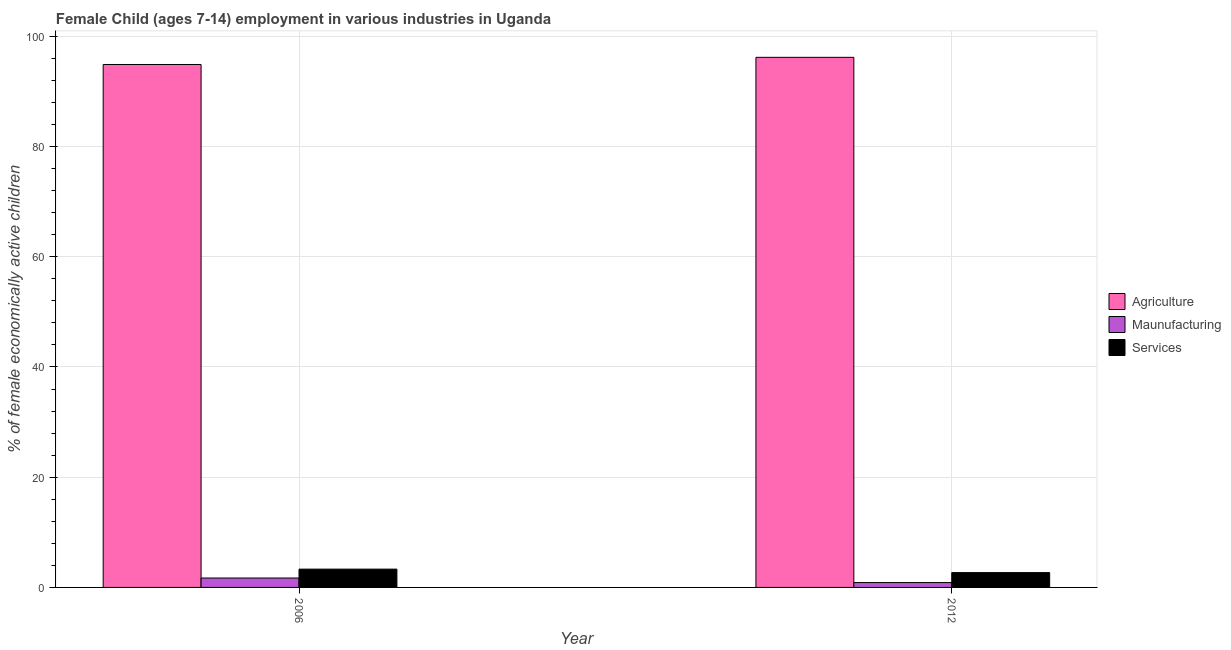Are the number of bars on each tick of the X-axis equal?
Your response must be concise. Yes. What is the label of the 2nd group of bars from the left?
Offer a terse response. 2012. What is the percentage of economically active children in services in 2006?
Keep it short and to the point. 3.32. Across all years, what is the maximum percentage of economically active children in manufacturing?
Provide a short and direct response. 1.71. Across all years, what is the minimum percentage of economically active children in manufacturing?
Provide a succinct answer. 0.88. In which year was the percentage of economically active children in agriculture minimum?
Provide a succinct answer. 2006. What is the total percentage of economically active children in agriculture in the graph?
Your answer should be compact. 191.08. What is the difference between the percentage of economically active children in agriculture in 2006 and that in 2012?
Your response must be concise. -1.3. What is the difference between the percentage of economically active children in manufacturing in 2006 and the percentage of economically active children in services in 2012?
Offer a terse response. 0.83. What is the average percentage of economically active children in services per year?
Provide a short and direct response. 3. In how many years, is the percentage of economically active children in services greater than 88 %?
Your answer should be compact. 0. What is the ratio of the percentage of economically active children in manufacturing in 2006 to that in 2012?
Offer a very short reply. 1.94. What does the 1st bar from the left in 2012 represents?
Make the answer very short. Agriculture. What does the 2nd bar from the right in 2012 represents?
Your answer should be very brief. Maunufacturing. What is the difference between two consecutive major ticks on the Y-axis?
Provide a short and direct response. 20. Does the graph contain any zero values?
Offer a very short reply. No. Does the graph contain grids?
Offer a terse response. Yes. How many legend labels are there?
Ensure brevity in your answer.  3. What is the title of the graph?
Offer a very short reply. Female Child (ages 7-14) employment in various industries in Uganda. Does "Manufactures" appear as one of the legend labels in the graph?
Ensure brevity in your answer.  No. What is the label or title of the X-axis?
Ensure brevity in your answer.  Year. What is the label or title of the Y-axis?
Your response must be concise. % of female economically active children. What is the % of female economically active children in Agriculture in 2006?
Keep it short and to the point. 94.89. What is the % of female economically active children of Maunufacturing in 2006?
Offer a terse response. 1.71. What is the % of female economically active children in Services in 2006?
Your response must be concise. 3.32. What is the % of female economically active children of Agriculture in 2012?
Keep it short and to the point. 96.19. What is the % of female economically active children in Services in 2012?
Make the answer very short. 2.69. Across all years, what is the maximum % of female economically active children of Agriculture?
Ensure brevity in your answer.  96.19. Across all years, what is the maximum % of female economically active children of Maunufacturing?
Your answer should be very brief. 1.71. Across all years, what is the maximum % of female economically active children in Services?
Provide a succinct answer. 3.32. Across all years, what is the minimum % of female economically active children in Agriculture?
Your answer should be compact. 94.89. Across all years, what is the minimum % of female economically active children of Services?
Make the answer very short. 2.69. What is the total % of female economically active children in Agriculture in the graph?
Keep it short and to the point. 191.08. What is the total % of female economically active children in Maunufacturing in the graph?
Ensure brevity in your answer.  2.59. What is the total % of female economically active children of Services in the graph?
Make the answer very short. 6.01. What is the difference between the % of female economically active children of Agriculture in 2006 and that in 2012?
Ensure brevity in your answer.  -1.3. What is the difference between the % of female economically active children in Maunufacturing in 2006 and that in 2012?
Offer a terse response. 0.83. What is the difference between the % of female economically active children in Services in 2006 and that in 2012?
Your answer should be compact. 0.63. What is the difference between the % of female economically active children of Agriculture in 2006 and the % of female economically active children of Maunufacturing in 2012?
Offer a very short reply. 94.01. What is the difference between the % of female economically active children in Agriculture in 2006 and the % of female economically active children in Services in 2012?
Offer a very short reply. 92.2. What is the difference between the % of female economically active children in Maunufacturing in 2006 and the % of female economically active children in Services in 2012?
Give a very brief answer. -0.98. What is the average % of female economically active children of Agriculture per year?
Provide a short and direct response. 95.54. What is the average % of female economically active children of Maunufacturing per year?
Make the answer very short. 1.29. What is the average % of female economically active children of Services per year?
Your answer should be very brief. 3. In the year 2006, what is the difference between the % of female economically active children of Agriculture and % of female economically active children of Maunufacturing?
Provide a succinct answer. 93.18. In the year 2006, what is the difference between the % of female economically active children of Agriculture and % of female economically active children of Services?
Make the answer very short. 91.57. In the year 2006, what is the difference between the % of female economically active children of Maunufacturing and % of female economically active children of Services?
Your answer should be compact. -1.61. In the year 2012, what is the difference between the % of female economically active children in Agriculture and % of female economically active children in Maunufacturing?
Offer a very short reply. 95.31. In the year 2012, what is the difference between the % of female economically active children in Agriculture and % of female economically active children in Services?
Offer a very short reply. 93.5. In the year 2012, what is the difference between the % of female economically active children in Maunufacturing and % of female economically active children in Services?
Offer a very short reply. -1.81. What is the ratio of the % of female economically active children of Agriculture in 2006 to that in 2012?
Make the answer very short. 0.99. What is the ratio of the % of female economically active children of Maunufacturing in 2006 to that in 2012?
Give a very brief answer. 1.94. What is the ratio of the % of female economically active children of Services in 2006 to that in 2012?
Offer a very short reply. 1.23. What is the difference between the highest and the second highest % of female economically active children of Agriculture?
Make the answer very short. 1.3. What is the difference between the highest and the second highest % of female economically active children of Maunufacturing?
Give a very brief answer. 0.83. What is the difference between the highest and the second highest % of female economically active children in Services?
Ensure brevity in your answer.  0.63. What is the difference between the highest and the lowest % of female economically active children in Maunufacturing?
Offer a very short reply. 0.83. What is the difference between the highest and the lowest % of female economically active children of Services?
Provide a succinct answer. 0.63. 